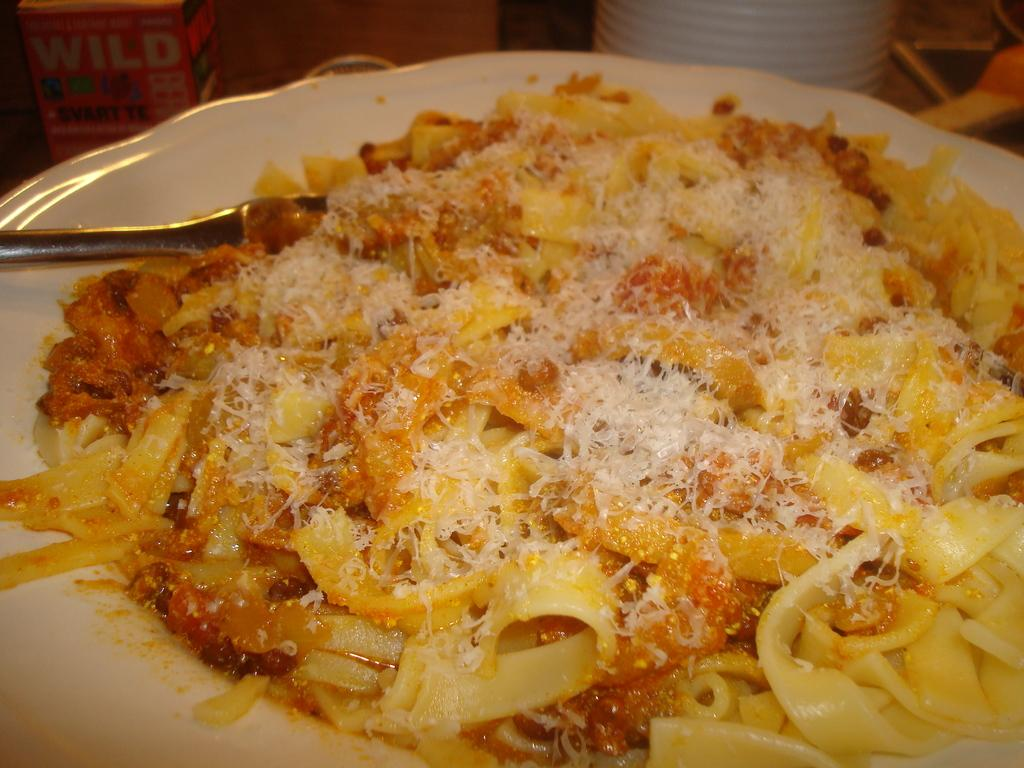What is located in the foreground of the image? There is food in the foreground of the image, along with a spoon on a platter. What can be seen in the background of the image? In the background, there are cups visible, as well as a cardboard box. Can you describe the utensil present in the foreground? Yes, there is a spoon on a platter in the foreground. What type of drink is being served in the mailbox in the image? There is no mailbox or drink present in the image. How does the peace symbol contribute to the image? There is no peace symbol present in the image. 